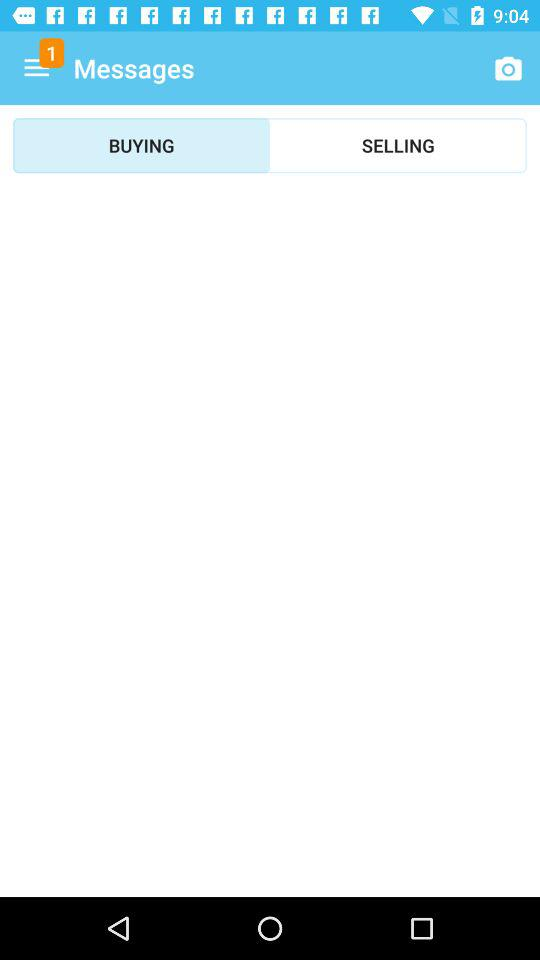What's the number of notifications at the menu bar? The number of notifications is 1. 